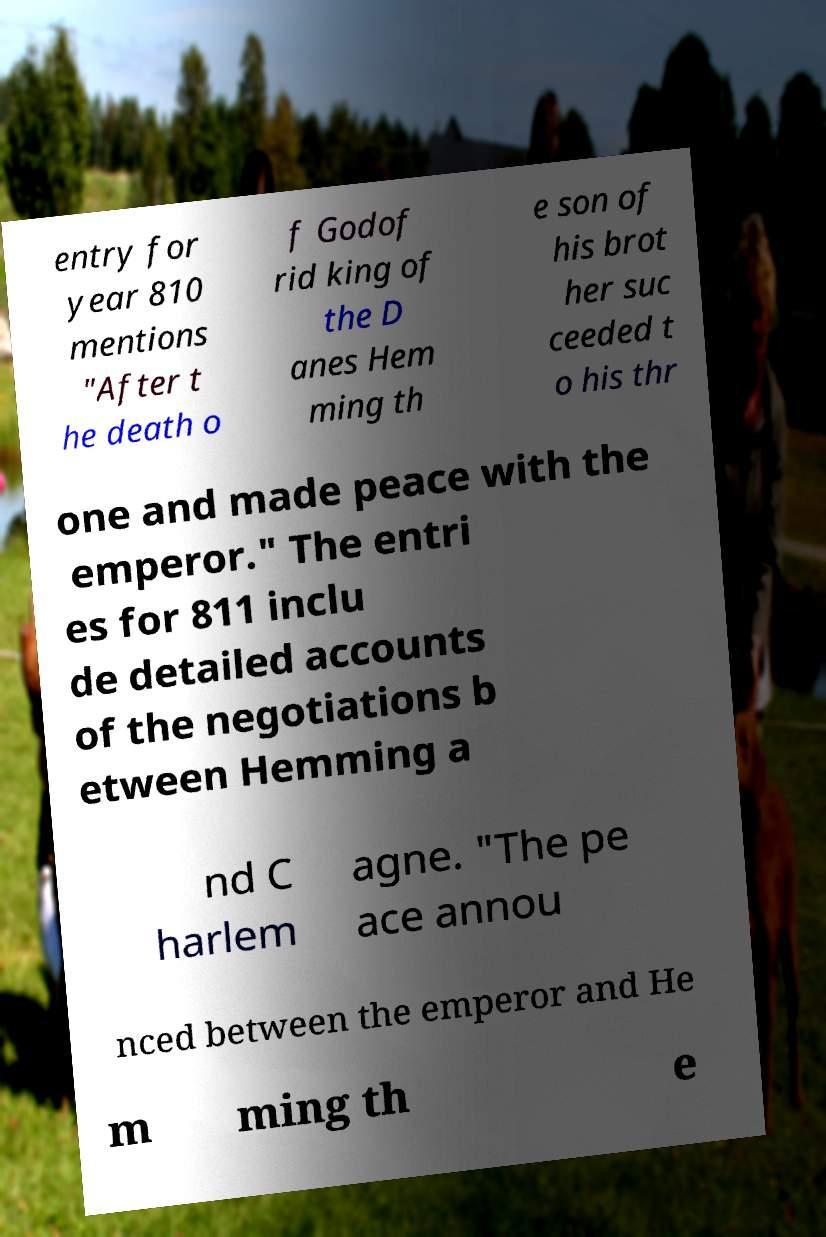Could you assist in decoding the text presented in this image and type it out clearly? entry for year 810 mentions "After t he death o f Godof rid king of the D anes Hem ming th e son of his brot her suc ceeded t o his thr one and made peace with the emperor." The entri es for 811 inclu de detailed accounts of the negotiations b etween Hemming a nd C harlem agne. "The pe ace annou nced between the emperor and He m ming th e 